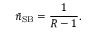<formula> <loc_0><loc_0><loc_500><loc_500>\bar { n } _ { S B } = \frac { 1 } { R - 1 } .</formula> 